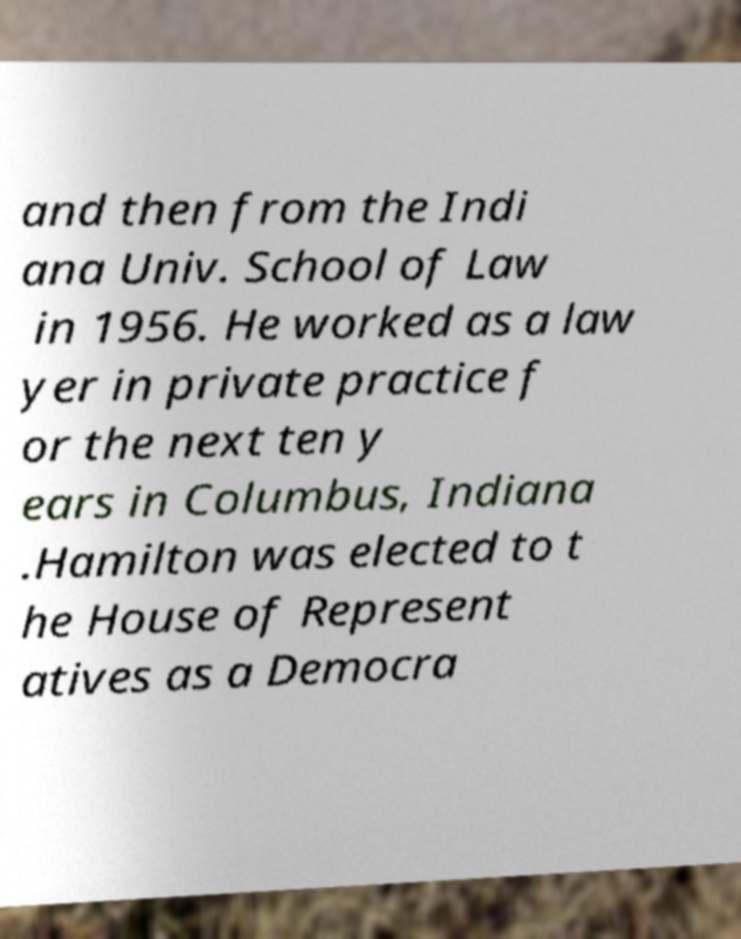Please identify and transcribe the text found in this image. and then from the Indi ana Univ. School of Law in 1956. He worked as a law yer in private practice f or the next ten y ears in Columbus, Indiana .Hamilton was elected to t he House of Represent atives as a Democra 